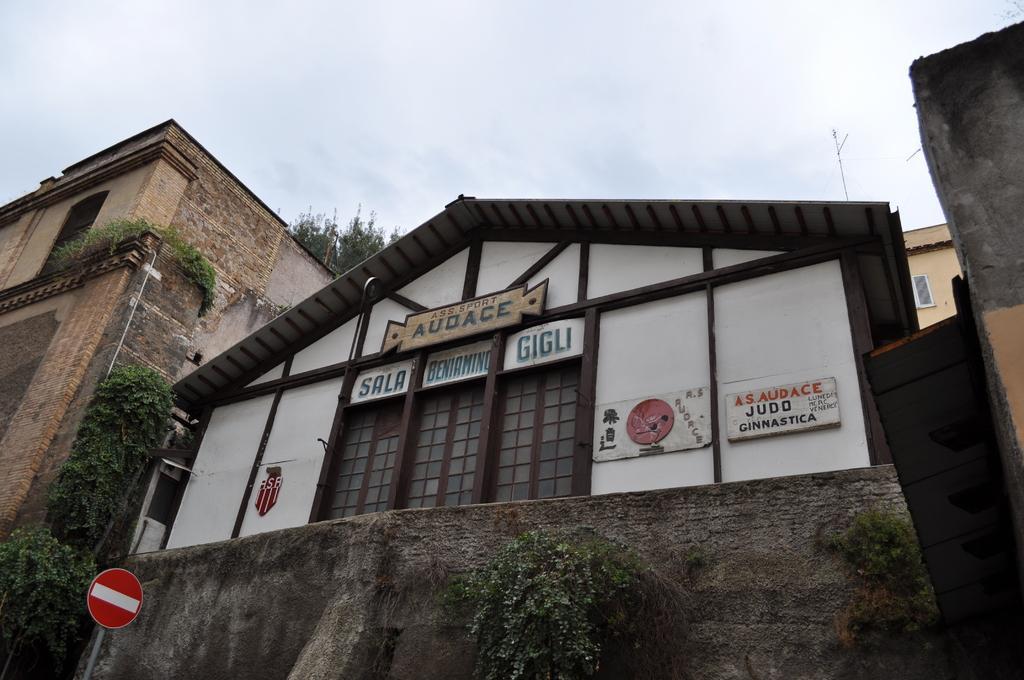Please provide a concise description of this image. In this image, there are a few houses. We can see some plants. We can also see a signboard. We can see the sky. We can see some boards with text written. 